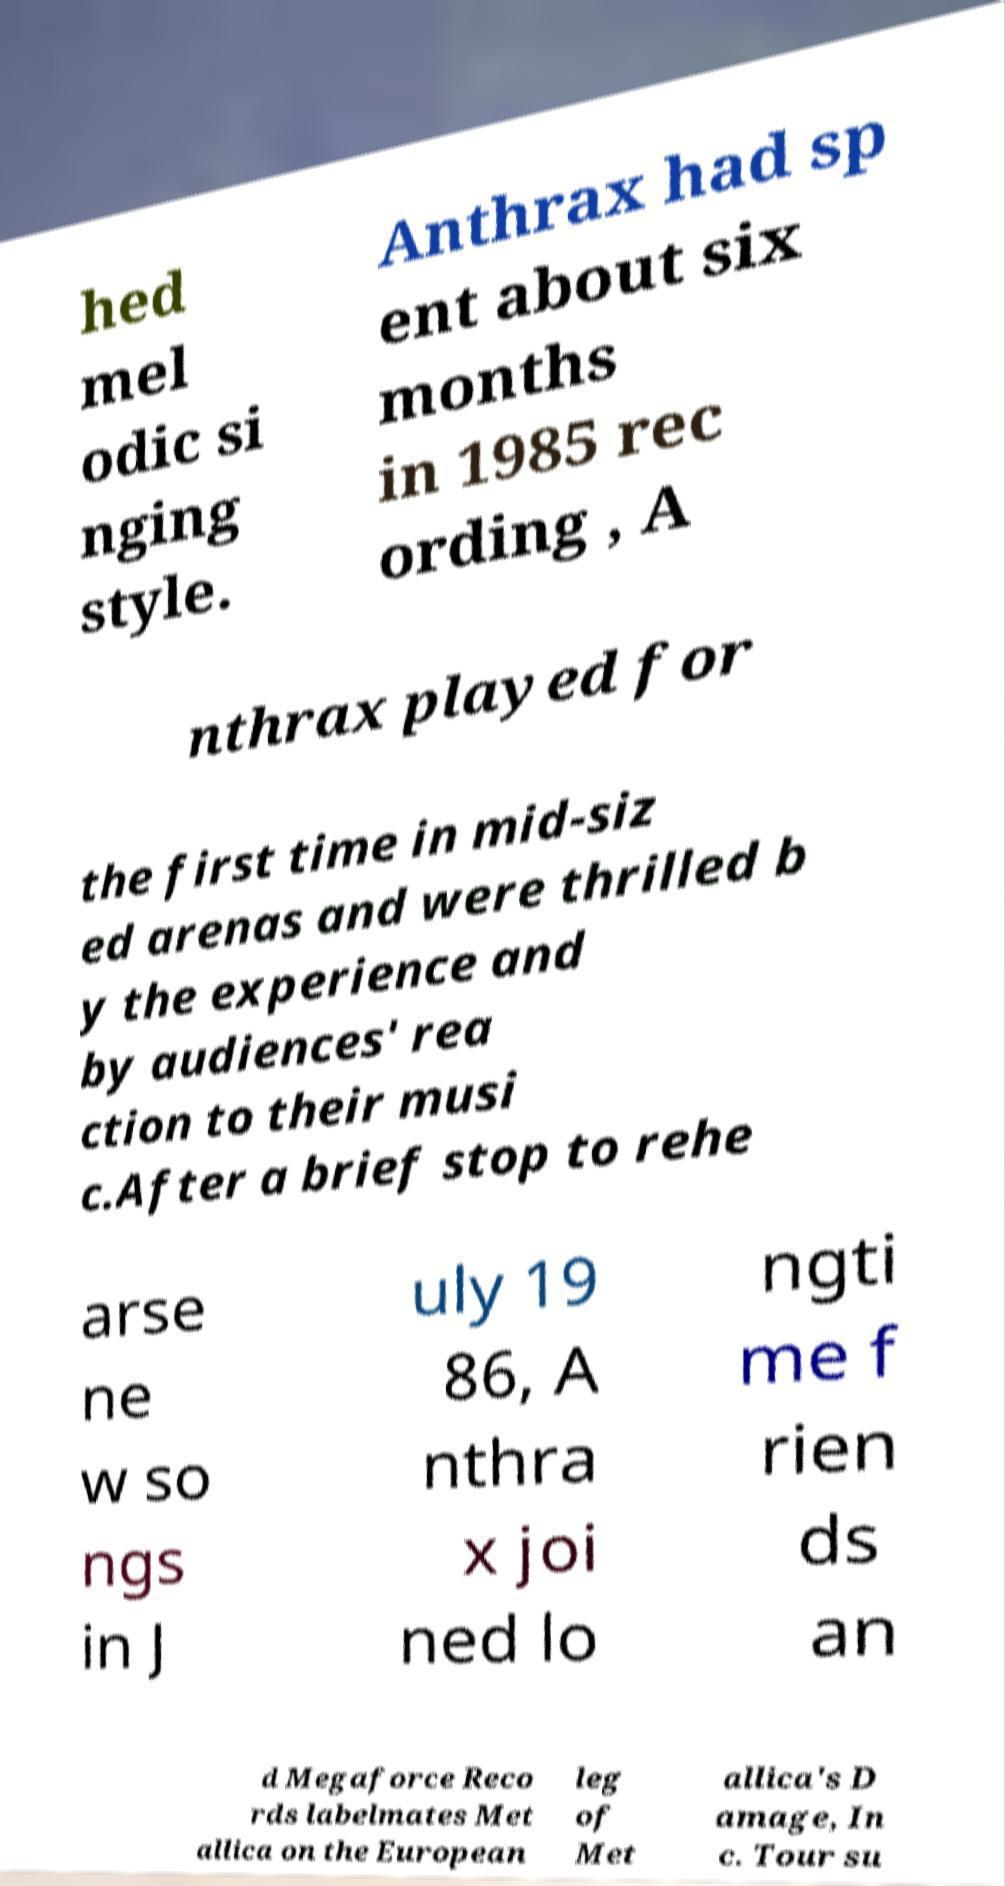Could you extract and type out the text from this image? hed mel odic si nging style. Anthrax had sp ent about six months in 1985 rec ording , A nthrax played for the first time in mid-siz ed arenas and were thrilled b y the experience and by audiences' rea ction to their musi c.After a brief stop to rehe arse ne w so ngs in J uly 19 86, A nthra x joi ned lo ngti me f rien ds an d Megaforce Reco rds labelmates Met allica on the European leg of Met allica's D amage, In c. Tour su 